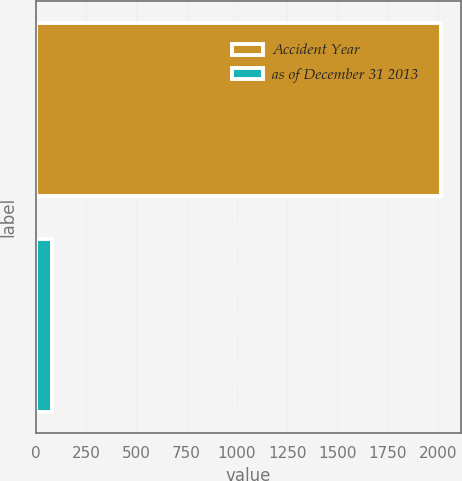Convert chart. <chart><loc_0><loc_0><loc_500><loc_500><bar_chart><fcel>Accident Year<fcel>as of December 31 2013<nl><fcel>2013<fcel>79<nl></chart> 